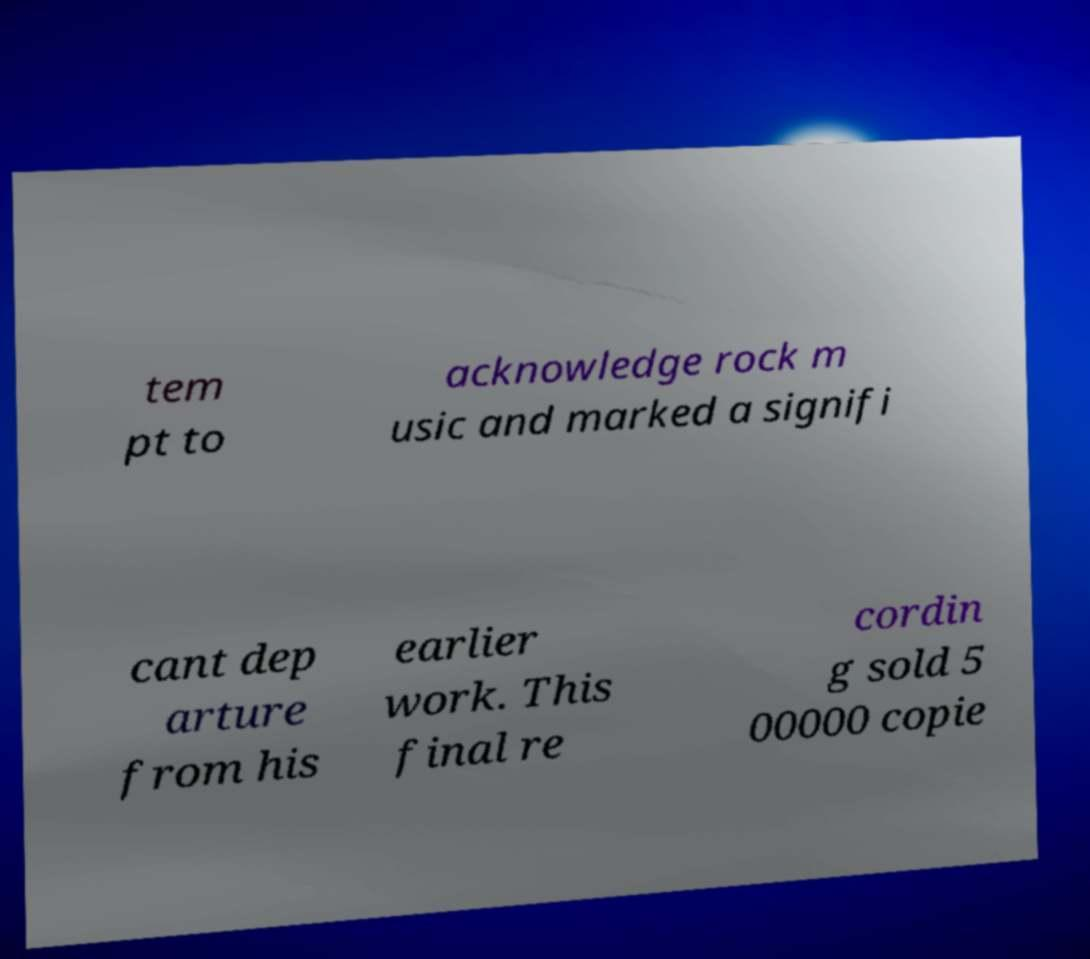Can you read and provide the text displayed in the image?This photo seems to have some interesting text. Can you extract and type it out for me? tem pt to acknowledge rock m usic and marked a signifi cant dep arture from his earlier work. This final re cordin g sold 5 00000 copie 